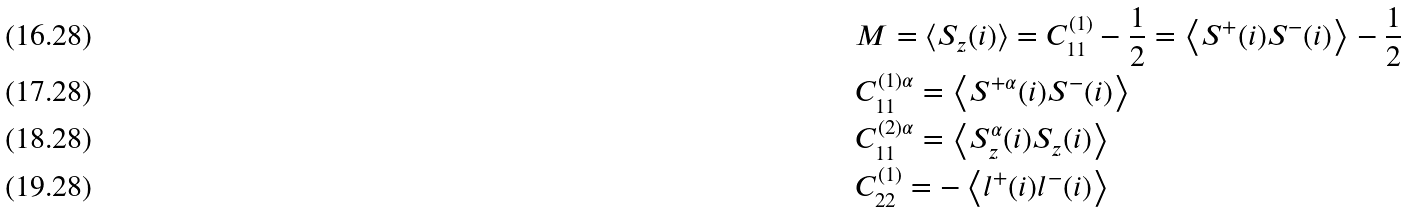<formula> <loc_0><loc_0><loc_500><loc_500>& M = \left \langle S _ { z } ( i ) \right \rangle = C _ { 1 1 } ^ { ( 1 ) } - \frac { 1 } { 2 } = \left \langle S ^ { + } ( i ) S ^ { - } ( i ) \right \rangle - \frac { 1 } { 2 } \\ & C _ { 1 1 } ^ { ( 1 ) \alpha } = \left \langle S ^ { + \alpha } ( i ) S ^ { - } ( i ) \right \rangle \\ & C _ { 1 1 } ^ { ( 2 ) \alpha } = \left \langle S _ { z } ^ { \alpha } ( i ) S _ { z } ( i ) \right \rangle \\ & C _ { 2 2 } ^ { ( 1 ) } = - \left \langle l ^ { + } ( i ) l ^ { - } ( i ) \right \rangle</formula> 